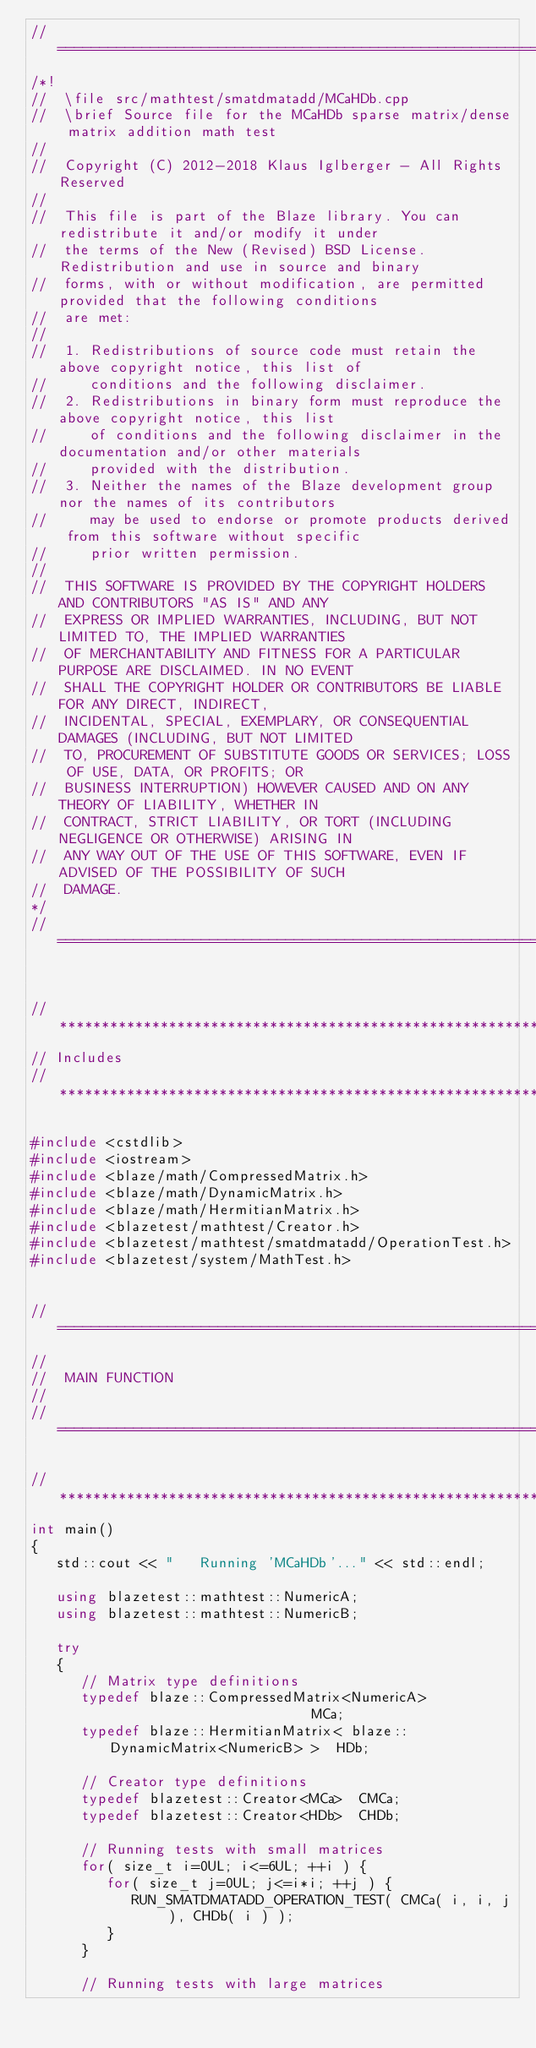<code> <loc_0><loc_0><loc_500><loc_500><_C++_>//=================================================================================================
/*!
//  \file src/mathtest/smatdmatadd/MCaHDb.cpp
//  \brief Source file for the MCaHDb sparse matrix/dense matrix addition math test
//
//  Copyright (C) 2012-2018 Klaus Iglberger - All Rights Reserved
//
//  This file is part of the Blaze library. You can redistribute it and/or modify it under
//  the terms of the New (Revised) BSD License. Redistribution and use in source and binary
//  forms, with or without modification, are permitted provided that the following conditions
//  are met:
//
//  1. Redistributions of source code must retain the above copyright notice, this list of
//     conditions and the following disclaimer.
//  2. Redistributions in binary form must reproduce the above copyright notice, this list
//     of conditions and the following disclaimer in the documentation and/or other materials
//     provided with the distribution.
//  3. Neither the names of the Blaze development group nor the names of its contributors
//     may be used to endorse or promote products derived from this software without specific
//     prior written permission.
//
//  THIS SOFTWARE IS PROVIDED BY THE COPYRIGHT HOLDERS AND CONTRIBUTORS "AS IS" AND ANY
//  EXPRESS OR IMPLIED WARRANTIES, INCLUDING, BUT NOT LIMITED TO, THE IMPLIED WARRANTIES
//  OF MERCHANTABILITY AND FITNESS FOR A PARTICULAR PURPOSE ARE DISCLAIMED. IN NO EVENT
//  SHALL THE COPYRIGHT HOLDER OR CONTRIBUTORS BE LIABLE FOR ANY DIRECT, INDIRECT,
//  INCIDENTAL, SPECIAL, EXEMPLARY, OR CONSEQUENTIAL DAMAGES (INCLUDING, BUT NOT LIMITED
//  TO, PROCUREMENT OF SUBSTITUTE GOODS OR SERVICES; LOSS OF USE, DATA, OR PROFITS; OR
//  BUSINESS INTERRUPTION) HOWEVER CAUSED AND ON ANY THEORY OF LIABILITY, WHETHER IN
//  CONTRACT, STRICT LIABILITY, OR TORT (INCLUDING NEGLIGENCE OR OTHERWISE) ARISING IN
//  ANY WAY OUT OF THE USE OF THIS SOFTWARE, EVEN IF ADVISED OF THE POSSIBILITY OF SUCH
//  DAMAGE.
*/
//=================================================================================================


//*************************************************************************************************
// Includes
//*************************************************************************************************

#include <cstdlib>
#include <iostream>
#include <blaze/math/CompressedMatrix.h>
#include <blaze/math/DynamicMatrix.h>
#include <blaze/math/HermitianMatrix.h>
#include <blazetest/mathtest/Creator.h>
#include <blazetest/mathtest/smatdmatadd/OperationTest.h>
#include <blazetest/system/MathTest.h>


//=================================================================================================
//
//  MAIN FUNCTION
//
//=================================================================================================

//*************************************************************************************************
int main()
{
   std::cout << "   Running 'MCaHDb'..." << std::endl;

   using blazetest::mathtest::NumericA;
   using blazetest::mathtest::NumericB;

   try
   {
      // Matrix type definitions
      typedef blaze::CompressedMatrix<NumericA>                         MCa;
      typedef blaze::HermitianMatrix< blaze::DynamicMatrix<NumericB> >  HDb;

      // Creator type definitions
      typedef blazetest::Creator<MCa>  CMCa;
      typedef blazetest::Creator<HDb>  CHDb;

      // Running tests with small matrices
      for( size_t i=0UL; i<=6UL; ++i ) {
         for( size_t j=0UL; j<=i*i; ++j ) {
            RUN_SMATDMATADD_OPERATION_TEST( CMCa( i, i, j ), CHDb( i ) );
         }
      }

      // Running tests with large matrices</code> 